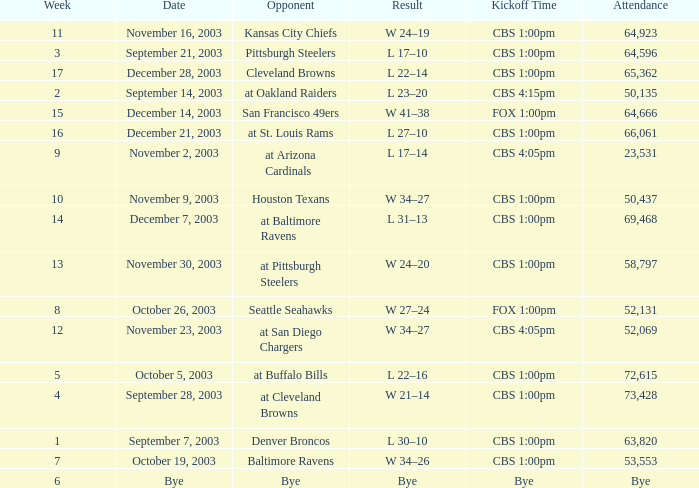What is the average number of weeks that the opponent was the Denver Broncos? 1.0. Could you parse the entire table? {'header': ['Week', 'Date', 'Opponent', 'Result', 'Kickoff Time', 'Attendance'], 'rows': [['11', 'November 16, 2003', 'Kansas City Chiefs', 'W 24–19', 'CBS 1:00pm', '64,923'], ['3', 'September 21, 2003', 'Pittsburgh Steelers', 'L 17–10', 'CBS 1:00pm', '64,596'], ['17', 'December 28, 2003', 'Cleveland Browns', 'L 22–14', 'CBS 1:00pm', '65,362'], ['2', 'September 14, 2003', 'at Oakland Raiders', 'L 23–20', 'CBS 4:15pm', '50,135'], ['15', 'December 14, 2003', 'San Francisco 49ers', 'W 41–38', 'FOX 1:00pm', '64,666'], ['16', 'December 21, 2003', 'at St. Louis Rams', 'L 27–10', 'CBS 1:00pm', '66,061'], ['9', 'November 2, 2003', 'at Arizona Cardinals', 'L 17–14', 'CBS 4:05pm', '23,531'], ['10', 'November 9, 2003', 'Houston Texans', 'W 34–27', 'CBS 1:00pm', '50,437'], ['14', 'December 7, 2003', 'at Baltimore Ravens', 'L 31–13', 'CBS 1:00pm', '69,468'], ['13', 'November 30, 2003', 'at Pittsburgh Steelers', 'W 24–20', 'CBS 1:00pm', '58,797'], ['8', 'October 26, 2003', 'Seattle Seahawks', 'W 27–24', 'FOX 1:00pm', '52,131'], ['12', 'November 23, 2003', 'at San Diego Chargers', 'W 34–27', 'CBS 4:05pm', '52,069'], ['5', 'October 5, 2003', 'at Buffalo Bills', 'L 22–16', 'CBS 1:00pm', '72,615'], ['4', 'September 28, 2003', 'at Cleveland Browns', 'W 21–14', 'CBS 1:00pm', '73,428'], ['1', 'September 7, 2003', 'Denver Broncos', 'L 30–10', 'CBS 1:00pm', '63,820'], ['7', 'October 19, 2003', 'Baltimore Ravens', 'W 34–26', 'CBS 1:00pm', '53,553'], ['6', 'Bye', 'Bye', 'Bye', 'Bye', 'Bye']]} 